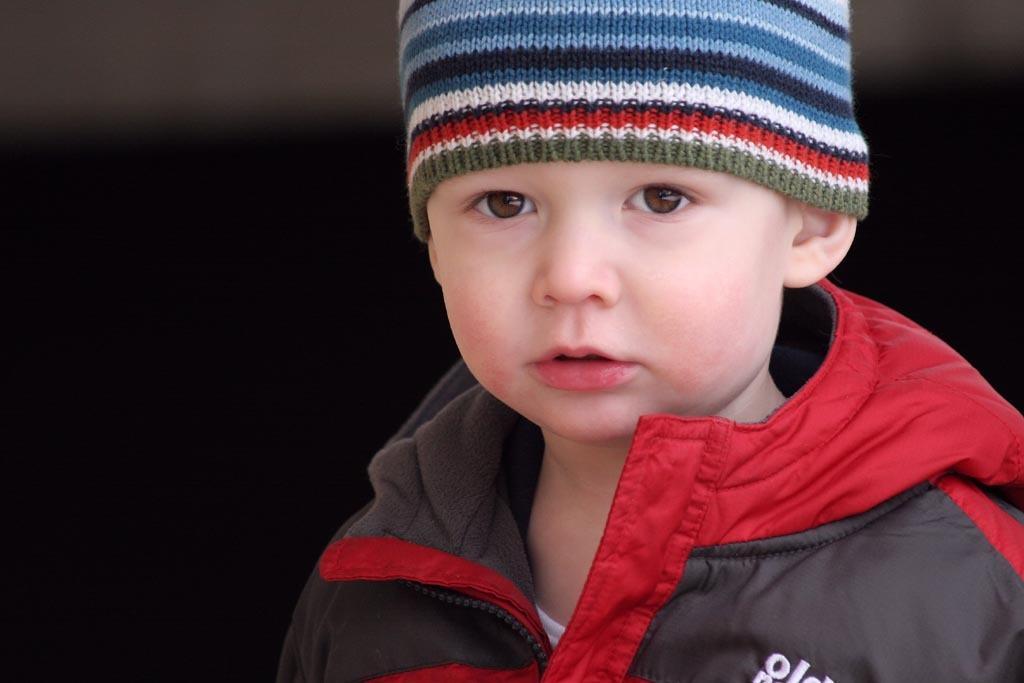In one or two sentences, can you explain what this image depicts? In this image, we can see a kid is watching and wearing a jacket and cap. Background it is dark. 